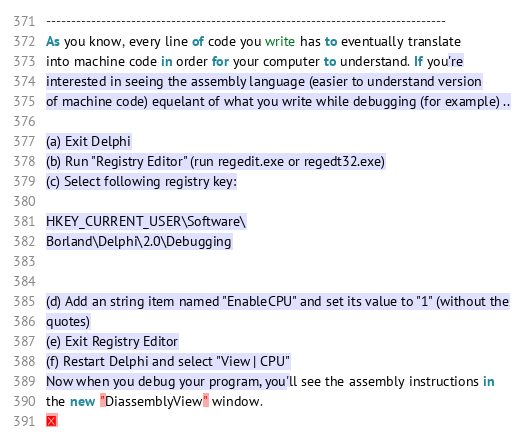Convert code to text. <code><loc_0><loc_0><loc_500><loc_500><_Pascal_>--------------------------------------------------------------------------------
As you know, every line of code you write has to eventually translate
into machine code in order for your computer to understand. If you're
interested in seeing the assembly language (easier to understand version
of machine code) equelant of what you write while debugging (for example) ..

(a) Exit Delphi
(b) Run "Registry Editor" (run regedit.exe or regedt32.exe)
(c) Select following registry key:

HKEY_CURRENT_USER\Software\
Borland\Delphi\2.0\Debugging


(d) Add an string item named "EnableCPU" and set its value to "1" (without the
quotes)
(e) Exit Registry Editor
(f) Restart Delphi and select "View | CPU"
Now when you debug your program, you'll see the assembly instructions in
the new "DiassemblyView" window.
</code> 